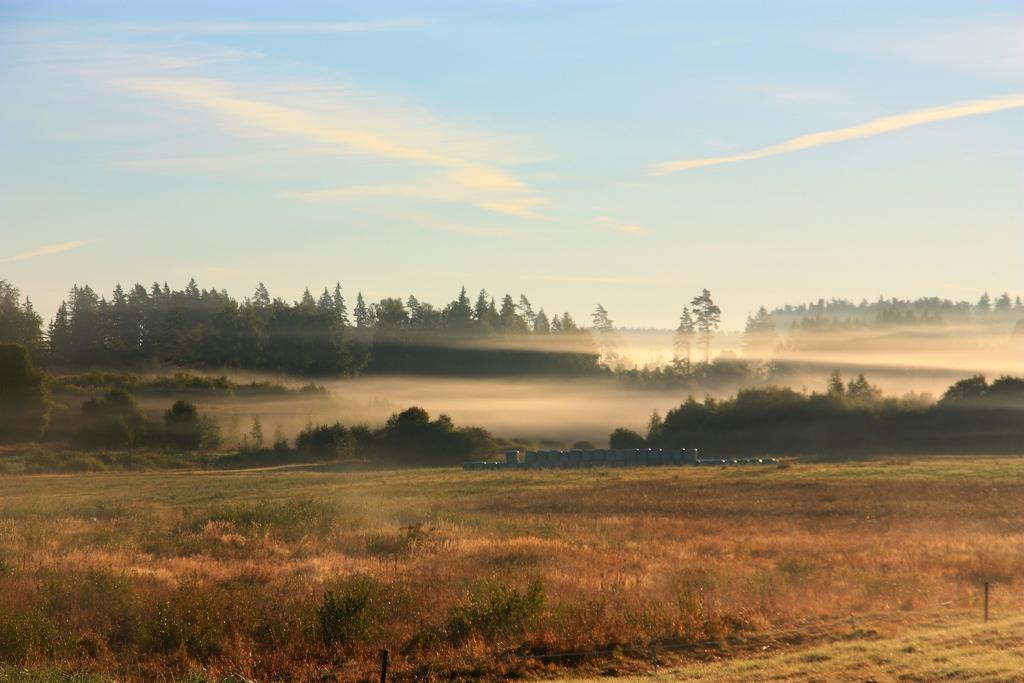What is located on the ground in the image? There are objects on the ground in the image. What type of natural vegetation can be seen in the image? There are trees visible in the image. What is visible in the background of the image? The sky is visible in the background of the image. What can be observed in the sky? Clouds are present in the sky. Can you tell me how many parents are visible in the image? There is no reference to parents in the image, so it is not possible to answer that question. What type of tent can be seen in the image? There is no tent present in the image. 